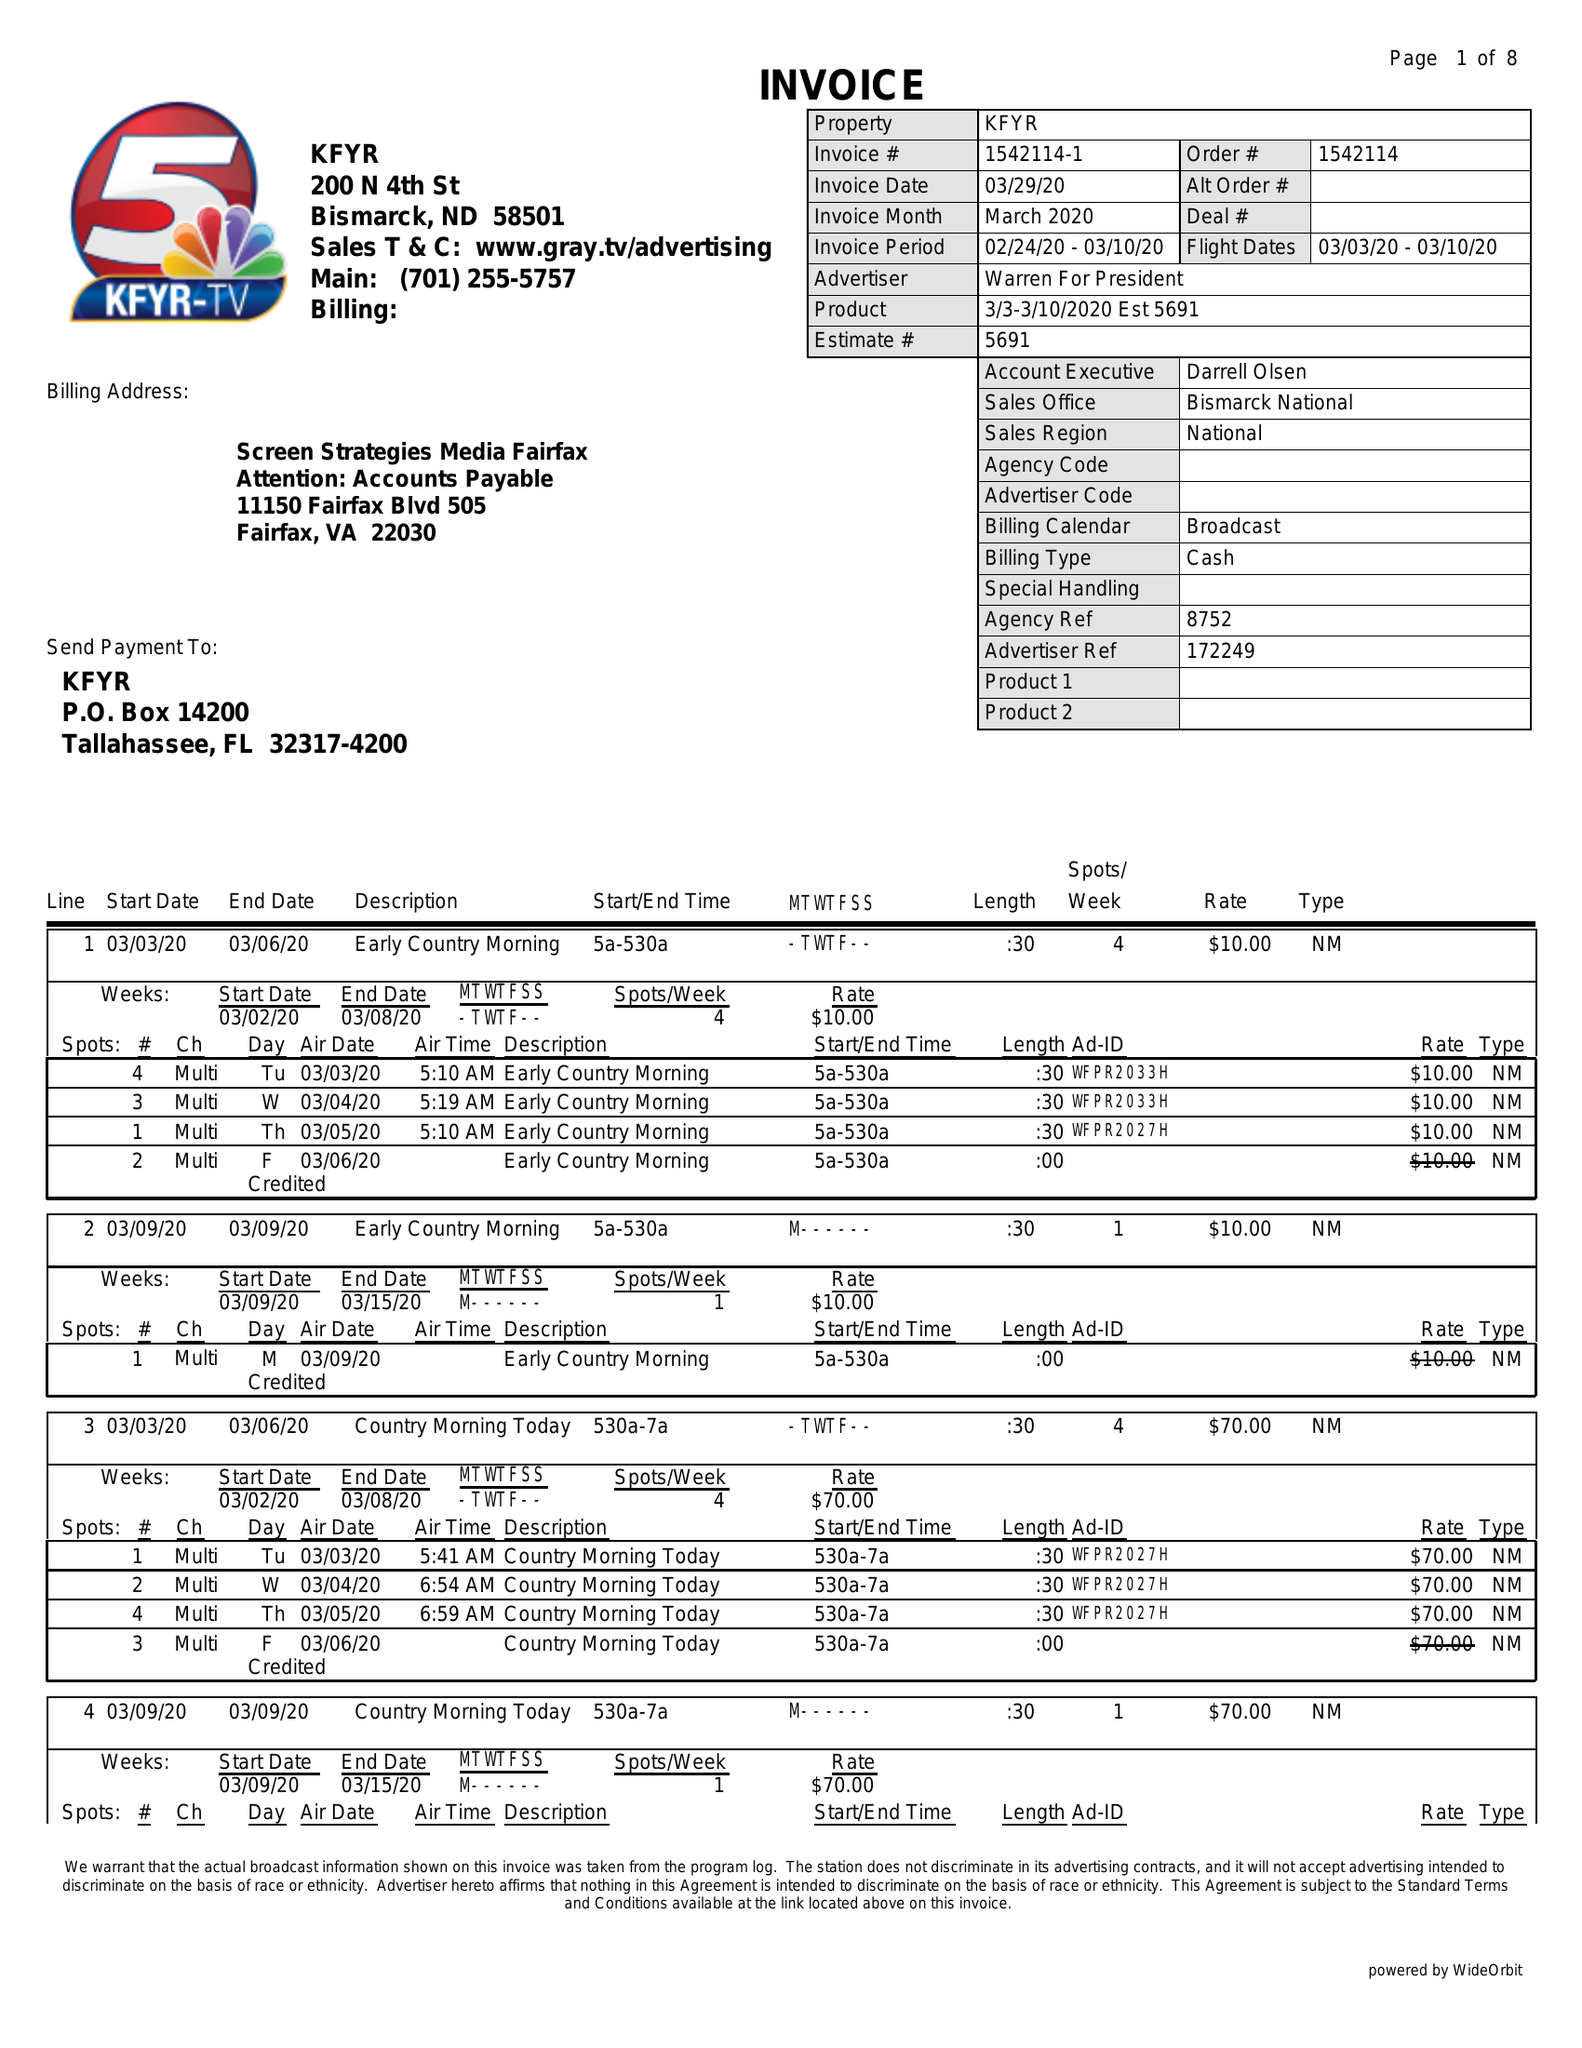What is the value for the advertiser?
Answer the question using a single word or phrase. WARREN FOR PRESIDENT 